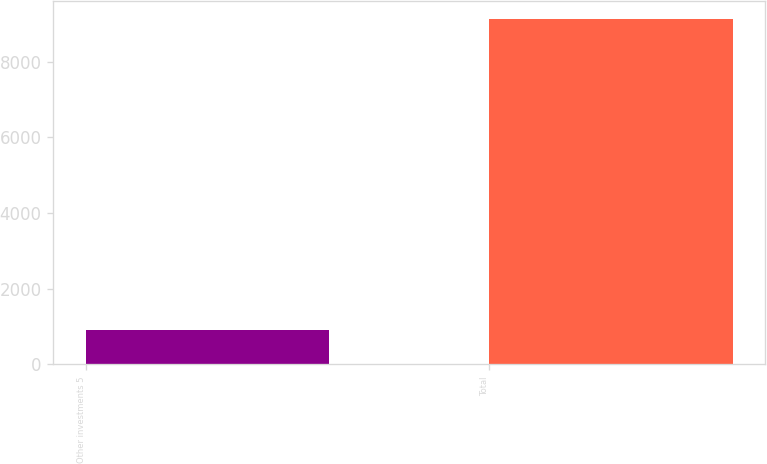Convert chart. <chart><loc_0><loc_0><loc_500><loc_500><bar_chart><fcel>Other investments 5<fcel>Total<nl><fcel>914<fcel>9131<nl></chart> 